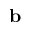<formula> <loc_0><loc_0><loc_500><loc_500>b</formula> 